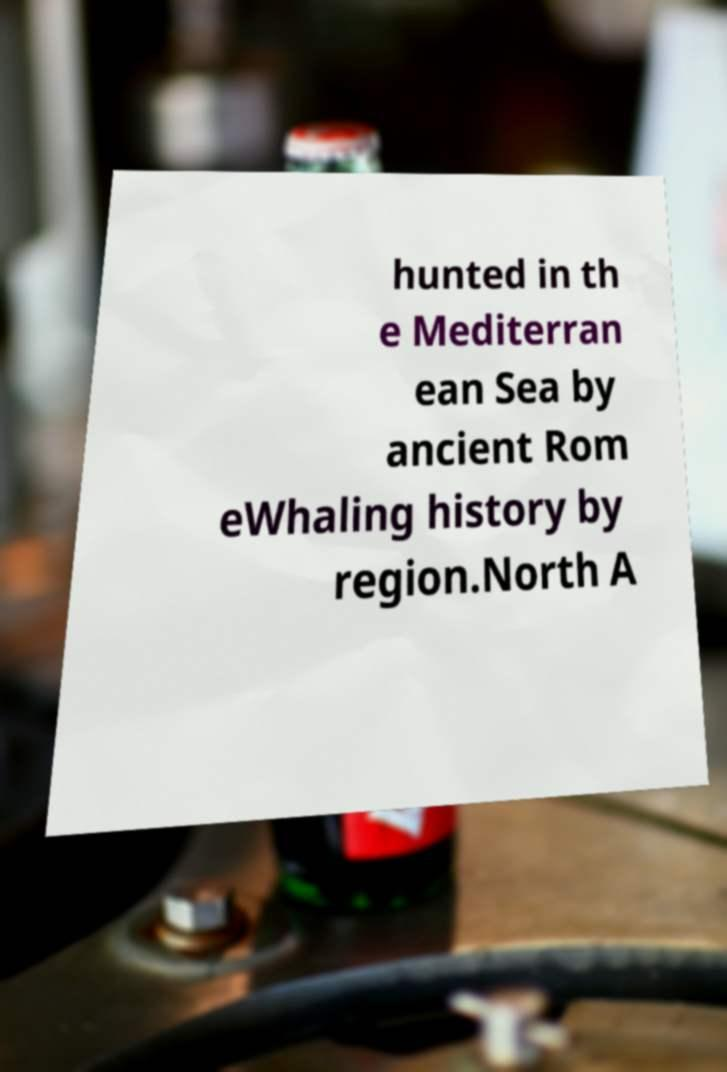I need the written content from this picture converted into text. Can you do that? hunted in th e Mediterran ean Sea by ancient Rom eWhaling history by region.North A 